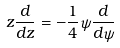<formula> <loc_0><loc_0><loc_500><loc_500>z \frac { d } { d z } = - \frac { 1 } { 4 } \psi \frac { d } { d \psi }</formula> 